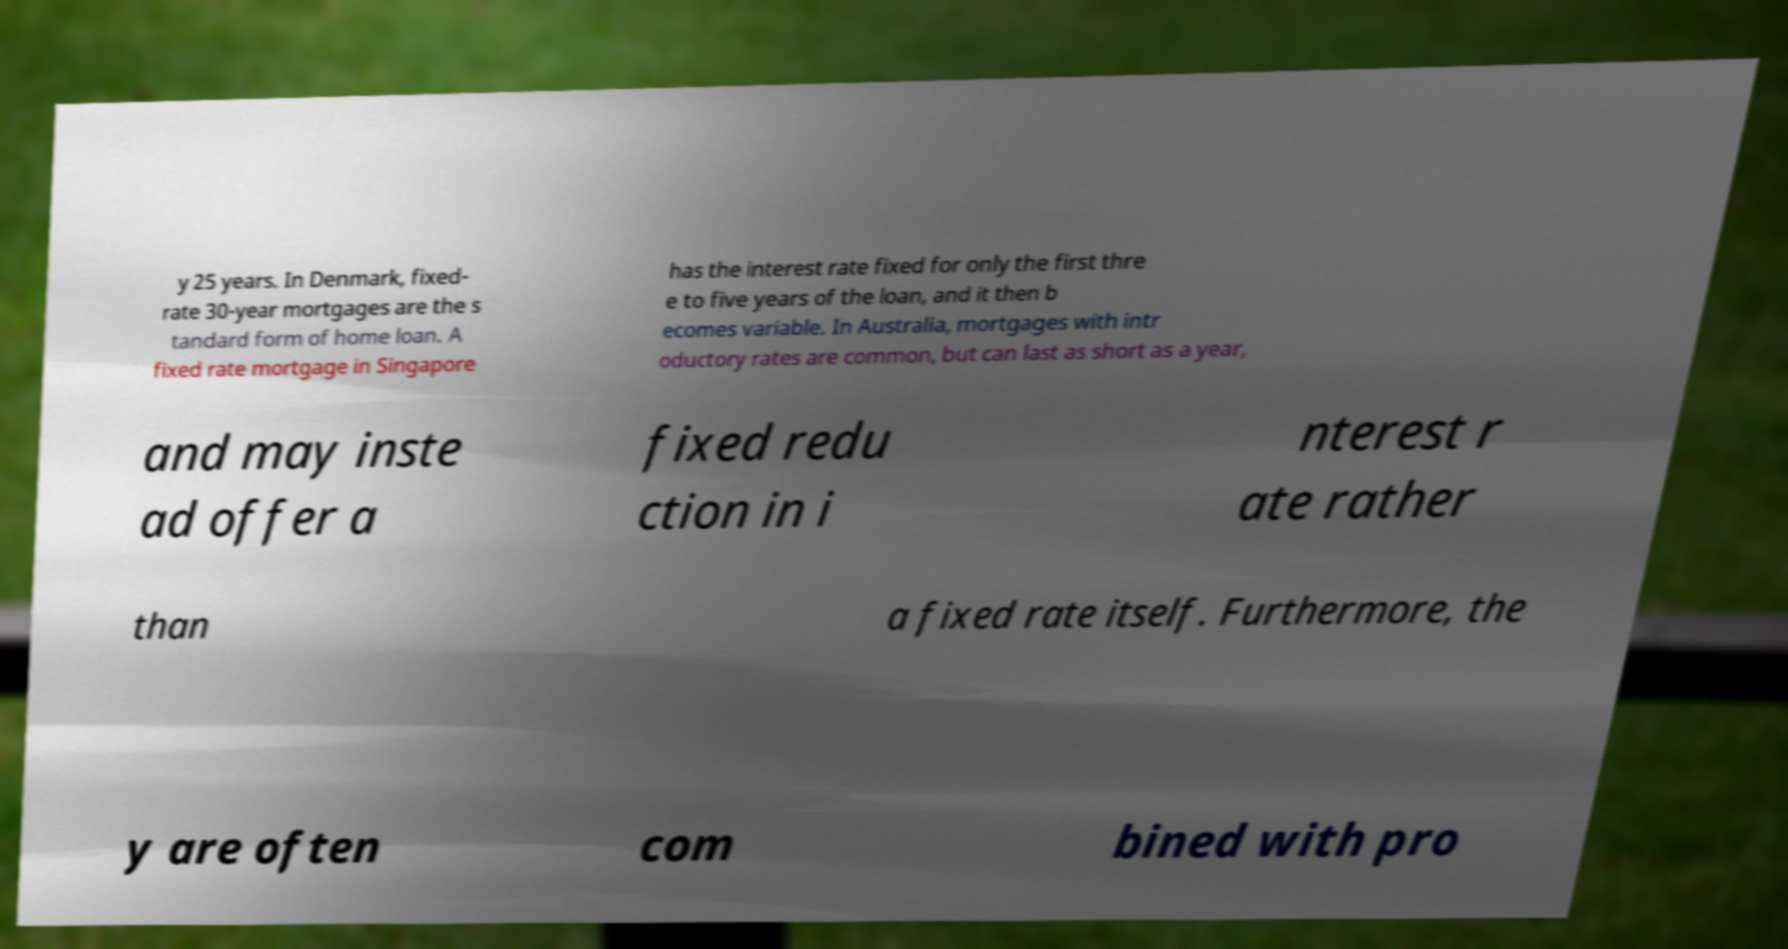Can you read and provide the text displayed in the image?This photo seems to have some interesting text. Can you extract and type it out for me? y 25 years. In Denmark, fixed- rate 30-year mortgages are the s tandard form of home loan. A fixed rate mortgage in Singapore has the interest rate fixed for only the first thre e to five years of the loan, and it then b ecomes variable. In Australia, mortgages with intr oductory rates are common, but can last as short as a year, and may inste ad offer a fixed redu ction in i nterest r ate rather than a fixed rate itself. Furthermore, the y are often com bined with pro 